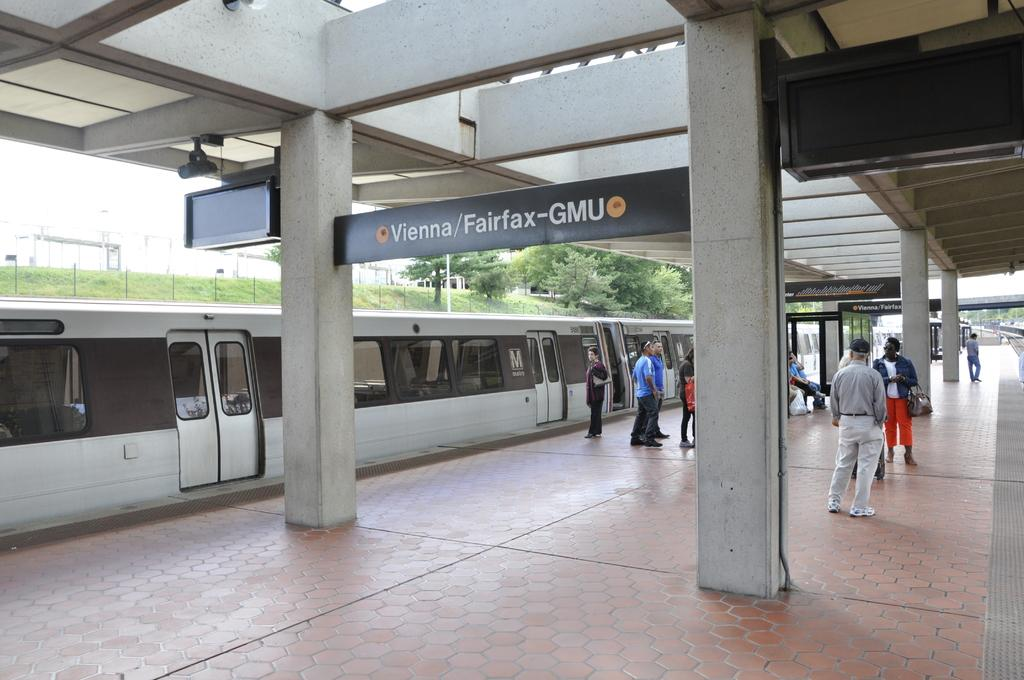What are the people in the image doing? The people in the image are standing on a platform. What is located behind the platform? There is a metro train standing behind the platform. What can be seen in the distance in the image? Trees are visible in the background of the image. How many cubes are being supported by the people on the platform? There are no cubes present in the image. What color are the eyes of the trees in the background? Trees do not have eyes, so this question cannot be answered. 